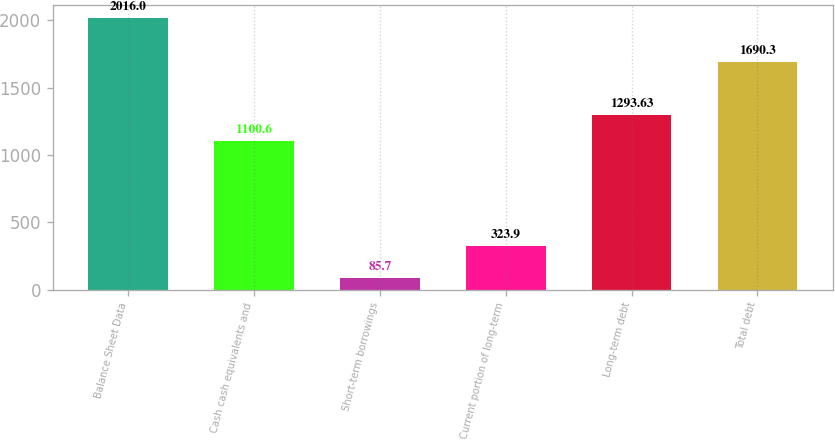Convert chart to OTSL. <chart><loc_0><loc_0><loc_500><loc_500><bar_chart><fcel>Balance Sheet Data<fcel>Cash cash equivalents and<fcel>Short-term borrowings<fcel>Current portion of long-term<fcel>Long-term debt<fcel>Total debt<nl><fcel>2016<fcel>1100.6<fcel>85.7<fcel>323.9<fcel>1293.63<fcel>1690.3<nl></chart> 